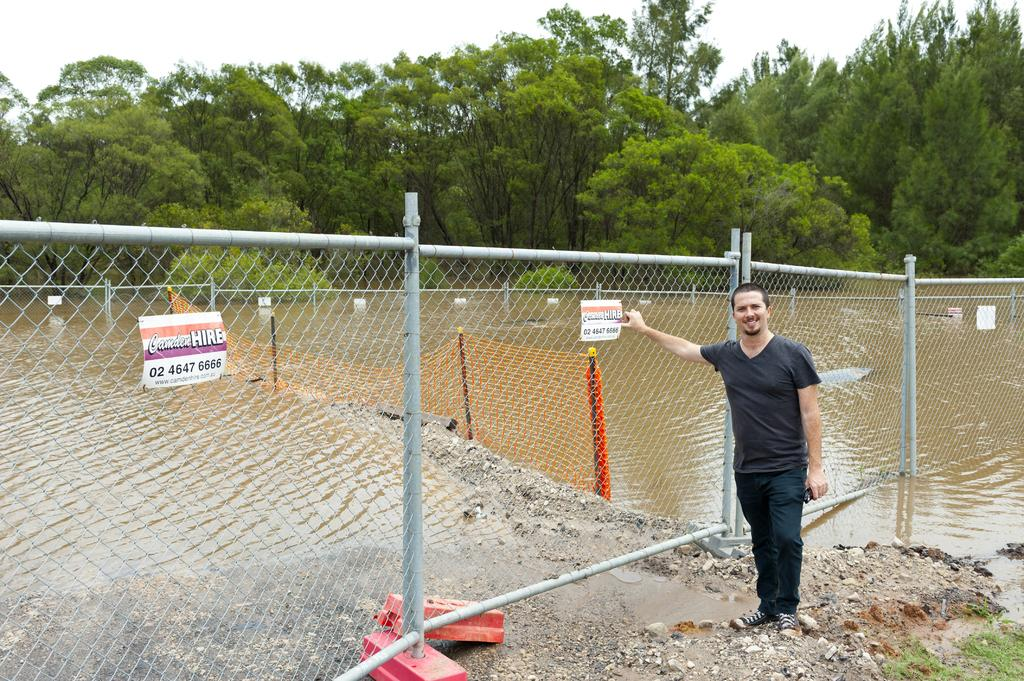What type of fencing is present in the image? There is a mesh fencing with poles in the image. What is attached to the fencing? There are posters on the fencing. Can you describe the person near the fencing? A person is standing near the fencing. What can be seen in the background of the image? Water, trees, and the sky are visible in the background of the image. What hobbies does the wind have in the image? There is no wind present in the image, and therefore no hobbies can be attributed to it. 